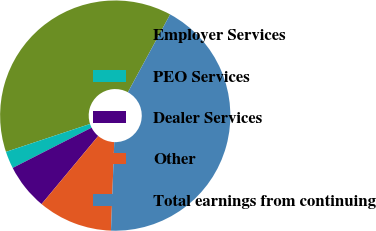Convert chart to OTSL. <chart><loc_0><loc_0><loc_500><loc_500><pie_chart><fcel>Employer Services<fcel>PEO Services<fcel>Dealer Services<fcel>Other<fcel>Total earnings from continuing<nl><fcel>38.01%<fcel>2.41%<fcel>6.44%<fcel>10.46%<fcel>42.67%<nl></chart> 